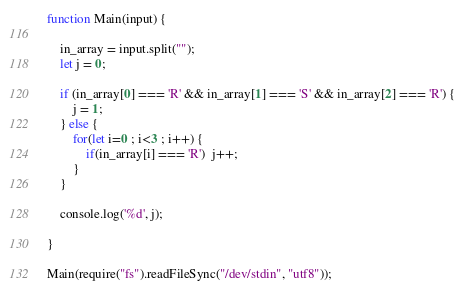<code> <loc_0><loc_0><loc_500><loc_500><_JavaScript_>function Main(input) {
 
    in_array = input.split("");
    let j = 0;
    
    if (in_array[0] === 'R' && in_array[1] === 'S' && in_array[2] === 'R') {
        j = 1;
    } else {
        for(let i=0 ; i<3 ; i++) {
            if(in_array[i] === 'R')  j++;
        }
    }
 
    console.log('%d', j);
    
}

Main(require("fs").readFileSync("/dev/stdin", "utf8"));</code> 